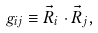<formula> <loc_0><loc_0><loc_500><loc_500>g _ { i j } \equiv \vec { R } _ { i } \cdot \vec { R } _ { j } ,</formula> 